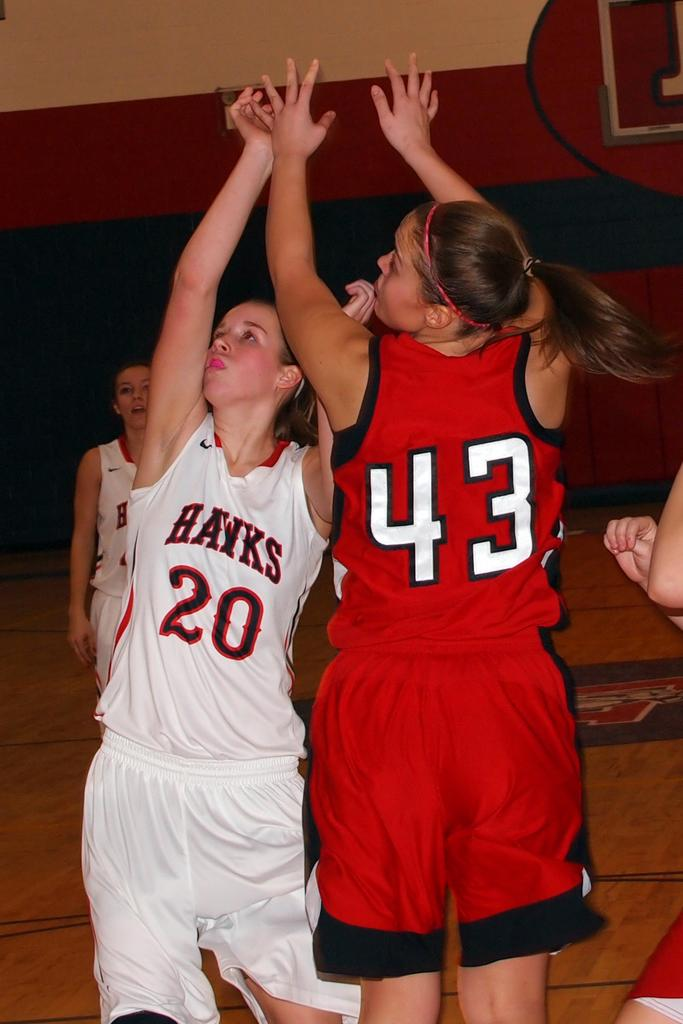<image>
Offer a succinct explanation of the picture presented. a girl with the number 43 on her jersey 